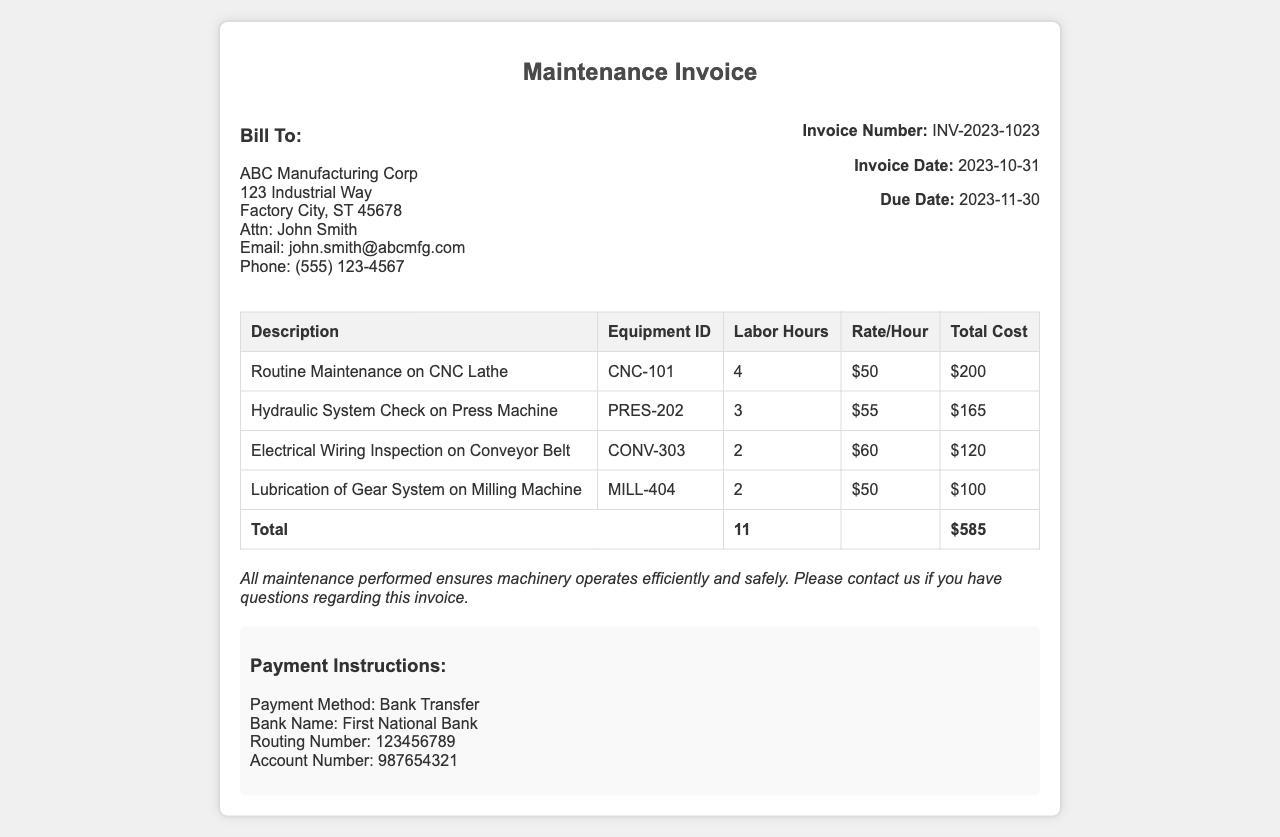What is the total cost of the maintenance services? The total cost is the sum of all individual service costs listed in the invoice, which amounts to $200 + $165 + $120 + $100 = $585.
Answer: $585 What is the due date for the invoice? The due date is explicitly stated in the invoice and is the date by which payment is required, which is November 30, 2023.
Answer: 2023-11-30 How many labor hours were billed in total? The total labor hours can be calculated by summing the individual hours listed for each service: 4 + 3 + 2 + 2 = 11 hours.
Answer: 11 Who is the contact person for billing inquiries? The contact person for billing inquiries is specified in the invoice, which mentions John Smith.
Answer: John Smith What is the rate per hour for the hydraulic system check? The rate per hour for the hydraulic system check is indicated next to the service description on the invoice, which is $55.
Answer: $55 What is the equipment ID for the CNC Lathe? The equipment ID for the CNC Lathe is provided in the table of services, which lists it as CNC-101.
Answer: CNC-101 What type of service was performed on the milling machine? The service performed on the milling machine is stated in the invoice, which describes it as lubrication of the gear system.
Answer: Lubrication of Gear System What payment method is specified in the invoice? The payment method is directly mentioned in the payment instructions section of the invoice, which states it is a bank transfer.
Answer: Bank Transfer 